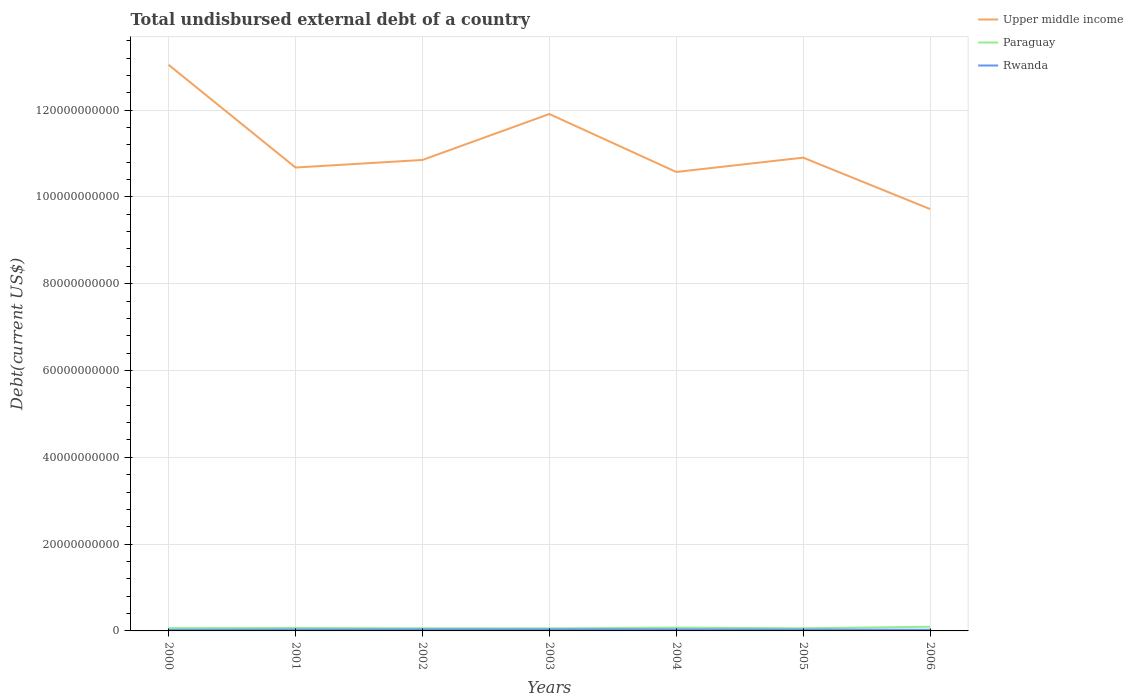Does the line corresponding to Rwanda intersect with the line corresponding to Upper middle income?
Offer a terse response. No. Is the number of lines equal to the number of legend labels?
Keep it short and to the point. Yes. Across all years, what is the maximum total undisbursed external debt in Upper middle income?
Provide a short and direct response. 9.72e+1. In which year was the total undisbursed external debt in Rwanda maximum?
Your answer should be very brief. 2000. What is the total total undisbursed external debt in Paraguay in the graph?
Offer a terse response. 4.14e+07. What is the difference between the highest and the second highest total undisbursed external debt in Upper middle income?
Offer a very short reply. 3.32e+1. Is the total undisbursed external debt in Paraguay strictly greater than the total undisbursed external debt in Rwanda over the years?
Offer a terse response. No. Are the values on the major ticks of Y-axis written in scientific E-notation?
Make the answer very short. No. Does the graph contain any zero values?
Provide a succinct answer. No. Where does the legend appear in the graph?
Make the answer very short. Top right. How many legend labels are there?
Ensure brevity in your answer.  3. How are the legend labels stacked?
Your answer should be compact. Vertical. What is the title of the graph?
Keep it short and to the point. Total undisbursed external debt of a country. Does "Lower middle income" appear as one of the legend labels in the graph?
Offer a very short reply. No. What is the label or title of the X-axis?
Offer a very short reply. Years. What is the label or title of the Y-axis?
Your answer should be compact. Debt(current US$). What is the Debt(current US$) in Upper middle income in 2000?
Your answer should be very brief. 1.30e+11. What is the Debt(current US$) of Paraguay in 2000?
Ensure brevity in your answer.  6.44e+08. What is the Debt(current US$) of Rwanda in 2000?
Provide a short and direct response. 2.42e+08. What is the Debt(current US$) of Upper middle income in 2001?
Offer a terse response. 1.07e+11. What is the Debt(current US$) in Paraguay in 2001?
Make the answer very short. 6.70e+08. What is the Debt(current US$) of Rwanda in 2001?
Your answer should be compact. 3.17e+08. What is the Debt(current US$) in Upper middle income in 2002?
Your answer should be compact. 1.09e+11. What is the Debt(current US$) of Paraguay in 2002?
Your answer should be compact. 6.13e+08. What is the Debt(current US$) in Rwanda in 2002?
Keep it short and to the point. 3.53e+08. What is the Debt(current US$) of Upper middle income in 2003?
Offer a terse response. 1.19e+11. What is the Debt(current US$) of Paraguay in 2003?
Make the answer very short. 5.88e+08. What is the Debt(current US$) in Rwanda in 2003?
Your answer should be compact. 3.61e+08. What is the Debt(current US$) of Upper middle income in 2004?
Keep it short and to the point. 1.06e+11. What is the Debt(current US$) in Paraguay in 2004?
Your answer should be compact. 7.51e+08. What is the Debt(current US$) in Rwanda in 2004?
Ensure brevity in your answer.  3.57e+08. What is the Debt(current US$) in Upper middle income in 2005?
Ensure brevity in your answer.  1.09e+11. What is the Debt(current US$) in Paraguay in 2005?
Give a very brief answer. 6.03e+08. What is the Debt(current US$) in Rwanda in 2005?
Provide a succinct answer. 3.08e+08. What is the Debt(current US$) of Upper middle income in 2006?
Give a very brief answer. 9.72e+1. What is the Debt(current US$) in Paraguay in 2006?
Provide a succinct answer. 9.66e+08. What is the Debt(current US$) in Rwanda in 2006?
Your response must be concise. 2.74e+08. Across all years, what is the maximum Debt(current US$) in Upper middle income?
Ensure brevity in your answer.  1.30e+11. Across all years, what is the maximum Debt(current US$) of Paraguay?
Make the answer very short. 9.66e+08. Across all years, what is the maximum Debt(current US$) in Rwanda?
Provide a short and direct response. 3.61e+08. Across all years, what is the minimum Debt(current US$) in Upper middle income?
Offer a very short reply. 9.72e+1. Across all years, what is the minimum Debt(current US$) in Paraguay?
Make the answer very short. 5.88e+08. Across all years, what is the minimum Debt(current US$) in Rwanda?
Ensure brevity in your answer.  2.42e+08. What is the total Debt(current US$) of Upper middle income in the graph?
Make the answer very short. 7.77e+11. What is the total Debt(current US$) in Paraguay in the graph?
Your response must be concise. 4.84e+09. What is the total Debt(current US$) of Rwanda in the graph?
Your response must be concise. 2.21e+09. What is the difference between the Debt(current US$) in Upper middle income in 2000 and that in 2001?
Keep it short and to the point. 2.37e+1. What is the difference between the Debt(current US$) of Paraguay in 2000 and that in 2001?
Your answer should be very brief. -2.57e+07. What is the difference between the Debt(current US$) in Rwanda in 2000 and that in 2001?
Your answer should be very brief. -7.55e+07. What is the difference between the Debt(current US$) of Upper middle income in 2000 and that in 2002?
Make the answer very short. 2.19e+1. What is the difference between the Debt(current US$) of Paraguay in 2000 and that in 2002?
Keep it short and to the point. 3.11e+07. What is the difference between the Debt(current US$) of Rwanda in 2000 and that in 2002?
Ensure brevity in your answer.  -1.12e+08. What is the difference between the Debt(current US$) of Upper middle income in 2000 and that in 2003?
Keep it short and to the point. 1.13e+1. What is the difference between the Debt(current US$) of Paraguay in 2000 and that in 2003?
Provide a short and direct response. 5.69e+07. What is the difference between the Debt(current US$) of Rwanda in 2000 and that in 2003?
Provide a succinct answer. -1.20e+08. What is the difference between the Debt(current US$) of Upper middle income in 2000 and that in 2004?
Make the answer very short. 2.47e+1. What is the difference between the Debt(current US$) of Paraguay in 2000 and that in 2004?
Provide a short and direct response. -1.06e+08. What is the difference between the Debt(current US$) of Rwanda in 2000 and that in 2004?
Provide a short and direct response. -1.16e+08. What is the difference between the Debt(current US$) in Upper middle income in 2000 and that in 2005?
Provide a succinct answer. 2.14e+1. What is the difference between the Debt(current US$) of Paraguay in 2000 and that in 2005?
Keep it short and to the point. 4.14e+07. What is the difference between the Debt(current US$) in Rwanda in 2000 and that in 2005?
Offer a very short reply. -6.67e+07. What is the difference between the Debt(current US$) in Upper middle income in 2000 and that in 2006?
Provide a short and direct response. 3.32e+1. What is the difference between the Debt(current US$) in Paraguay in 2000 and that in 2006?
Provide a short and direct response. -3.22e+08. What is the difference between the Debt(current US$) of Rwanda in 2000 and that in 2006?
Provide a short and direct response. -3.26e+07. What is the difference between the Debt(current US$) in Upper middle income in 2001 and that in 2002?
Your answer should be very brief. -1.75e+09. What is the difference between the Debt(current US$) in Paraguay in 2001 and that in 2002?
Keep it short and to the point. 5.68e+07. What is the difference between the Debt(current US$) of Rwanda in 2001 and that in 2002?
Provide a short and direct response. -3.62e+07. What is the difference between the Debt(current US$) of Upper middle income in 2001 and that in 2003?
Your response must be concise. -1.23e+1. What is the difference between the Debt(current US$) in Paraguay in 2001 and that in 2003?
Your response must be concise. 8.26e+07. What is the difference between the Debt(current US$) in Rwanda in 2001 and that in 2003?
Provide a short and direct response. -4.42e+07. What is the difference between the Debt(current US$) in Upper middle income in 2001 and that in 2004?
Provide a succinct answer. 1.02e+09. What is the difference between the Debt(current US$) in Paraguay in 2001 and that in 2004?
Your response must be concise. -8.05e+07. What is the difference between the Debt(current US$) in Rwanda in 2001 and that in 2004?
Offer a terse response. -4.03e+07. What is the difference between the Debt(current US$) in Upper middle income in 2001 and that in 2005?
Keep it short and to the point. -2.28e+09. What is the difference between the Debt(current US$) of Paraguay in 2001 and that in 2005?
Give a very brief answer. 6.71e+07. What is the difference between the Debt(current US$) in Rwanda in 2001 and that in 2005?
Offer a very short reply. 8.79e+06. What is the difference between the Debt(current US$) in Upper middle income in 2001 and that in 2006?
Your answer should be very brief. 9.57e+09. What is the difference between the Debt(current US$) in Paraguay in 2001 and that in 2006?
Make the answer very short. -2.96e+08. What is the difference between the Debt(current US$) of Rwanda in 2001 and that in 2006?
Your answer should be very brief. 4.29e+07. What is the difference between the Debt(current US$) of Upper middle income in 2002 and that in 2003?
Give a very brief answer. -1.06e+1. What is the difference between the Debt(current US$) of Paraguay in 2002 and that in 2003?
Your response must be concise. 2.58e+07. What is the difference between the Debt(current US$) in Rwanda in 2002 and that in 2003?
Your response must be concise. -8.06e+06. What is the difference between the Debt(current US$) in Upper middle income in 2002 and that in 2004?
Keep it short and to the point. 2.77e+09. What is the difference between the Debt(current US$) of Paraguay in 2002 and that in 2004?
Keep it short and to the point. -1.37e+08. What is the difference between the Debt(current US$) of Rwanda in 2002 and that in 2004?
Ensure brevity in your answer.  -4.13e+06. What is the difference between the Debt(current US$) in Upper middle income in 2002 and that in 2005?
Your response must be concise. -5.31e+08. What is the difference between the Debt(current US$) in Paraguay in 2002 and that in 2005?
Give a very brief answer. 1.03e+07. What is the difference between the Debt(current US$) in Rwanda in 2002 and that in 2005?
Make the answer very short. 4.50e+07. What is the difference between the Debt(current US$) of Upper middle income in 2002 and that in 2006?
Your response must be concise. 1.13e+1. What is the difference between the Debt(current US$) in Paraguay in 2002 and that in 2006?
Provide a succinct answer. -3.53e+08. What is the difference between the Debt(current US$) in Rwanda in 2002 and that in 2006?
Offer a very short reply. 7.90e+07. What is the difference between the Debt(current US$) of Upper middle income in 2003 and that in 2004?
Provide a short and direct response. 1.33e+1. What is the difference between the Debt(current US$) of Paraguay in 2003 and that in 2004?
Offer a very short reply. -1.63e+08. What is the difference between the Debt(current US$) in Rwanda in 2003 and that in 2004?
Your answer should be very brief. 3.93e+06. What is the difference between the Debt(current US$) in Upper middle income in 2003 and that in 2005?
Keep it short and to the point. 1.01e+1. What is the difference between the Debt(current US$) of Paraguay in 2003 and that in 2005?
Ensure brevity in your answer.  -1.55e+07. What is the difference between the Debt(current US$) of Rwanda in 2003 and that in 2005?
Your answer should be compact. 5.30e+07. What is the difference between the Debt(current US$) in Upper middle income in 2003 and that in 2006?
Make the answer very short. 2.19e+1. What is the difference between the Debt(current US$) of Paraguay in 2003 and that in 2006?
Your response must be concise. -3.79e+08. What is the difference between the Debt(current US$) of Rwanda in 2003 and that in 2006?
Your answer should be very brief. 8.71e+07. What is the difference between the Debt(current US$) in Upper middle income in 2004 and that in 2005?
Your answer should be very brief. -3.30e+09. What is the difference between the Debt(current US$) of Paraguay in 2004 and that in 2005?
Your response must be concise. 1.48e+08. What is the difference between the Debt(current US$) in Rwanda in 2004 and that in 2005?
Make the answer very short. 4.91e+07. What is the difference between the Debt(current US$) in Upper middle income in 2004 and that in 2006?
Provide a short and direct response. 8.55e+09. What is the difference between the Debt(current US$) of Paraguay in 2004 and that in 2006?
Keep it short and to the point. -2.16e+08. What is the difference between the Debt(current US$) in Rwanda in 2004 and that in 2006?
Your response must be concise. 8.32e+07. What is the difference between the Debt(current US$) in Upper middle income in 2005 and that in 2006?
Your answer should be compact. 1.18e+1. What is the difference between the Debt(current US$) in Paraguay in 2005 and that in 2006?
Your answer should be compact. -3.63e+08. What is the difference between the Debt(current US$) in Rwanda in 2005 and that in 2006?
Your answer should be very brief. 3.41e+07. What is the difference between the Debt(current US$) of Upper middle income in 2000 and the Debt(current US$) of Paraguay in 2001?
Your answer should be very brief. 1.30e+11. What is the difference between the Debt(current US$) in Upper middle income in 2000 and the Debt(current US$) in Rwanda in 2001?
Offer a very short reply. 1.30e+11. What is the difference between the Debt(current US$) of Paraguay in 2000 and the Debt(current US$) of Rwanda in 2001?
Make the answer very short. 3.27e+08. What is the difference between the Debt(current US$) in Upper middle income in 2000 and the Debt(current US$) in Paraguay in 2002?
Your answer should be very brief. 1.30e+11. What is the difference between the Debt(current US$) in Upper middle income in 2000 and the Debt(current US$) in Rwanda in 2002?
Offer a very short reply. 1.30e+11. What is the difference between the Debt(current US$) in Paraguay in 2000 and the Debt(current US$) in Rwanda in 2002?
Provide a short and direct response. 2.91e+08. What is the difference between the Debt(current US$) of Upper middle income in 2000 and the Debt(current US$) of Paraguay in 2003?
Provide a short and direct response. 1.30e+11. What is the difference between the Debt(current US$) of Upper middle income in 2000 and the Debt(current US$) of Rwanda in 2003?
Offer a terse response. 1.30e+11. What is the difference between the Debt(current US$) of Paraguay in 2000 and the Debt(current US$) of Rwanda in 2003?
Provide a succinct answer. 2.83e+08. What is the difference between the Debt(current US$) of Upper middle income in 2000 and the Debt(current US$) of Paraguay in 2004?
Ensure brevity in your answer.  1.30e+11. What is the difference between the Debt(current US$) of Upper middle income in 2000 and the Debt(current US$) of Rwanda in 2004?
Your answer should be very brief. 1.30e+11. What is the difference between the Debt(current US$) in Paraguay in 2000 and the Debt(current US$) in Rwanda in 2004?
Give a very brief answer. 2.87e+08. What is the difference between the Debt(current US$) of Upper middle income in 2000 and the Debt(current US$) of Paraguay in 2005?
Your response must be concise. 1.30e+11. What is the difference between the Debt(current US$) of Upper middle income in 2000 and the Debt(current US$) of Rwanda in 2005?
Provide a short and direct response. 1.30e+11. What is the difference between the Debt(current US$) of Paraguay in 2000 and the Debt(current US$) of Rwanda in 2005?
Provide a short and direct response. 3.36e+08. What is the difference between the Debt(current US$) in Upper middle income in 2000 and the Debt(current US$) in Paraguay in 2006?
Give a very brief answer. 1.29e+11. What is the difference between the Debt(current US$) of Upper middle income in 2000 and the Debt(current US$) of Rwanda in 2006?
Give a very brief answer. 1.30e+11. What is the difference between the Debt(current US$) in Paraguay in 2000 and the Debt(current US$) in Rwanda in 2006?
Ensure brevity in your answer.  3.70e+08. What is the difference between the Debt(current US$) in Upper middle income in 2001 and the Debt(current US$) in Paraguay in 2002?
Give a very brief answer. 1.06e+11. What is the difference between the Debt(current US$) in Upper middle income in 2001 and the Debt(current US$) in Rwanda in 2002?
Your answer should be compact. 1.06e+11. What is the difference between the Debt(current US$) in Paraguay in 2001 and the Debt(current US$) in Rwanda in 2002?
Provide a succinct answer. 3.17e+08. What is the difference between the Debt(current US$) in Upper middle income in 2001 and the Debt(current US$) in Paraguay in 2003?
Your response must be concise. 1.06e+11. What is the difference between the Debt(current US$) in Upper middle income in 2001 and the Debt(current US$) in Rwanda in 2003?
Offer a very short reply. 1.06e+11. What is the difference between the Debt(current US$) in Paraguay in 2001 and the Debt(current US$) in Rwanda in 2003?
Make the answer very short. 3.09e+08. What is the difference between the Debt(current US$) in Upper middle income in 2001 and the Debt(current US$) in Paraguay in 2004?
Ensure brevity in your answer.  1.06e+11. What is the difference between the Debt(current US$) of Upper middle income in 2001 and the Debt(current US$) of Rwanda in 2004?
Keep it short and to the point. 1.06e+11. What is the difference between the Debt(current US$) in Paraguay in 2001 and the Debt(current US$) in Rwanda in 2004?
Keep it short and to the point. 3.13e+08. What is the difference between the Debt(current US$) in Upper middle income in 2001 and the Debt(current US$) in Paraguay in 2005?
Offer a terse response. 1.06e+11. What is the difference between the Debt(current US$) in Upper middle income in 2001 and the Debt(current US$) in Rwanda in 2005?
Your answer should be very brief. 1.06e+11. What is the difference between the Debt(current US$) of Paraguay in 2001 and the Debt(current US$) of Rwanda in 2005?
Offer a very short reply. 3.62e+08. What is the difference between the Debt(current US$) in Upper middle income in 2001 and the Debt(current US$) in Paraguay in 2006?
Provide a succinct answer. 1.06e+11. What is the difference between the Debt(current US$) of Upper middle income in 2001 and the Debt(current US$) of Rwanda in 2006?
Your answer should be very brief. 1.06e+11. What is the difference between the Debt(current US$) in Paraguay in 2001 and the Debt(current US$) in Rwanda in 2006?
Your answer should be compact. 3.96e+08. What is the difference between the Debt(current US$) of Upper middle income in 2002 and the Debt(current US$) of Paraguay in 2003?
Provide a short and direct response. 1.08e+11. What is the difference between the Debt(current US$) in Upper middle income in 2002 and the Debt(current US$) in Rwanda in 2003?
Your response must be concise. 1.08e+11. What is the difference between the Debt(current US$) of Paraguay in 2002 and the Debt(current US$) of Rwanda in 2003?
Your answer should be very brief. 2.52e+08. What is the difference between the Debt(current US$) in Upper middle income in 2002 and the Debt(current US$) in Paraguay in 2004?
Offer a terse response. 1.08e+11. What is the difference between the Debt(current US$) in Upper middle income in 2002 and the Debt(current US$) in Rwanda in 2004?
Give a very brief answer. 1.08e+11. What is the difference between the Debt(current US$) of Paraguay in 2002 and the Debt(current US$) of Rwanda in 2004?
Offer a very short reply. 2.56e+08. What is the difference between the Debt(current US$) in Upper middle income in 2002 and the Debt(current US$) in Paraguay in 2005?
Offer a terse response. 1.08e+11. What is the difference between the Debt(current US$) of Upper middle income in 2002 and the Debt(current US$) of Rwanda in 2005?
Make the answer very short. 1.08e+11. What is the difference between the Debt(current US$) in Paraguay in 2002 and the Debt(current US$) in Rwanda in 2005?
Offer a terse response. 3.05e+08. What is the difference between the Debt(current US$) in Upper middle income in 2002 and the Debt(current US$) in Paraguay in 2006?
Offer a very short reply. 1.08e+11. What is the difference between the Debt(current US$) of Upper middle income in 2002 and the Debt(current US$) of Rwanda in 2006?
Offer a very short reply. 1.08e+11. What is the difference between the Debt(current US$) of Paraguay in 2002 and the Debt(current US$) of Rwanda in 2006?
Provide a short and direct response. 3.39e+08. What is the difference between the Debt(current US$) in Upper middle income in 2003 and the Debt(current US$) in Paraguay in 2004?
Keep it short and to the point. 1.18e+11. What is the difference between the Debt(current US$) in Upper middle income in 2003 and the Debt(current US$) in Rwanda in 2004?
Your response must be concise. 1.19e+11. What is the difference between the Debt(current US$) in Paraguay in 2003 and the Debt(current US$) in Rwanda in 2004?
Give a very brief answer. 2.30e+08. What is the difference between the Debt(current US$) of Upper middle income in 2003 and the Debt(current US$) of Paraguay in 2005?
Provide a succinct answer. 1.18e+11. What is the difference between the Debt(current US$) in Upper middle income in 2003 and the Debt(current US$) in Rwanda in 2005?
Your answer should be compact. 1.19e+11. What is the difference between the Debt(current US$) in Paraguay in 2003 and the Debt(current US$) in Rwanda in 2005?
Offer a very short reply. 2.79e+08. What is the difference between the Debt(current US$) in Upper middle income in 2003 and the Debt(current US$) in Paraguay in 2006?
Provide a succinct answer. 1.18e+11. What is the difference between the Debt(current US$) in Upper middle income in 2003 and the Debt(current US$) in Rwanda in 2006?
Provide a short and direct response. 1.19e+11. What is the difference between the Debt(current US$) in Paraguay in 2003 and the Debt(current US$) in Rwanda in 2006?
Offer a very short reply. 3.13e+08. What is the difference between the Debt(current US$) in Upper middle income in 2004 and the Debt(current US$) in Paraguay in 2005?
Your answer should be compact. 1.05e+11. What is the difference between the Debt(current US$) in Upper middle income in 2004 and the Debt(current US$) in Rwanda in 2005?
Ensure brevity in your answer.  1.05e+11. What is the difference between the Debt(current US$) of Paraguay in 2004 and the Debt(current US$) of Rwanda in 2005?
Offer a terse response. 4.42e+08. What is the difference between the Debt(current US$) in Upper middle income in 2004 and the Debt(current US$) in Paraguay in 2006?
Your response must be concise. 1.05e+11. What is the difference between the Debt(current US$) in Upper middle income in 2004 and the Debt(current US$) in Rwanda in 2006?
Provide a succinct answer. 1.05e+11. What is the difference between the Debt(current US$) of Paraguay in 2004 and the Debt(current US$) of Rwanda in 2006?
Your answer should be very brief. 4.76e+08. What is the difference between the Debt(current US$) in Upper middle income in 2005 and the Debt(current US$) in Paraguay in 2006?
Make the answer very short. 1.08e+11. What is the difference between the Debt(current US$) of Upper middle income in 2005 and the Debt(current US$) of Rwanda in 2006?
Your response must be concise. 1.09e+11. What is the difference between the Debt(current US$) in Paraguay in 2005 and the Debt(current US$) in Rwanda in 2006?
Your answer should be very brief. 3.29e+08. What is the average Debt(current US$) in Upper middle income per year?
Provide a short and direct response. 1.11e+11. What is the average Debt(current US$) of Paraguay per year?
Make the answer very short. 6.91e+08. What is the average Debt(current US$) in Rwanda per year?
Provide a succinct answer. 3.16e+08. In the year 2000, what is the difference between the Debt(current US$) of Upper middle income and Debt(current US$) of Paraguay?
Your answer should be very brief. 1.30e+11. In the year 2000, what is the difference between the Debt(current US$) of Upper middle income and Debt(current US$) of Rwanda?
Offer a terse response. 1.30e+11. In the year 2000, what is the difference between the Debt(current US$) of Paraguay and Debt(current US$) of Rwanda?
Give a very brief answer. 4.03e+08. In the year 2001, what is the difference between the Debt(current US$) in Upper middle income and Debt(current US$) in Paraguay?
Give a very brief answer. 1.06e+11. In the year 2001, what is the difference between the Debt(current US$) in Upper middle income and Debt(current US$) in Rwanda?
Give a very brief answer. 1.06e+11. In the year 2001, what is the difference between the Debt(current US$) in Paraguay and Debt(current US$) in Rwanda?
Offer a terse response. 3.53e+08. In the year 2002, what is the difference between the Debt(current US$) in Upper middle income and Debt(current US$) in Paraguay?
Make the answer very short. 1.08e+11. In the year 2002, what is the difference between the Debt(current US$) of Upper middle income and Debt(current US$) of Rwanda?
Offer a terse response. 1.08e+11. In the year 2002, what is the difference between the Debt(current US$) in Paraguay and Debt(current US$) in Rwanda?
Your answer should be compact. 2.60e+08. In the year 2003, what is the difference between the Debt(current US$) of Upper middle income and Debt(current US$) of Paraguay?
Make the answer very short. 1.19e+11. In the year 2003, what is the difference between the Debt(current US$) in Upper middle income and Debt(current US$) in Rwanda?
Give a very brief answer. 1.19e+11. In the year 2003, what is the difference between the Debt(current US$) in Paraguay and Debt(current US$) in Rwanda?
Provide a succinct answer. 2.26e+08. In the year 2004, what is the difference between the Debt(current US$) in Upper middle income and Debt(current US$) in Paraguay?
Offer a terse response. 1.05e+11. In the year 2004, what is the difference between the Debt(current US$) in Upper middle income and Debt(current US$) in Rwanda?
Ensure brevity in your answer.  1.05e+11. In the year 2004, what is the difference between the Debt(current US$) in Paraguay and Debt(current US$) in Rwanda?
Ensure brevity in your answer.  3.93e+08. In the year 2005, what is the difference between the Debt(current US$) of Upper middle income and Debt(current US$) of Paraguay?
Provide a short and direct response. 1.08e+11. In the year 2005, what is the difference between the Debt(current US$) in Upper middle income and Debt(current US$) in Rwanda?
Ensure brevity in your answer.  1.09e+11. In the year 2005, what is the difference between the Debt(current US$) in Paraguay and Debt(current US$) in Rwanda?
Your response must be concise. 2.95e+08. In the year 2006, what is the difference between the Debt(current US$) of Upper middle income and Debt(current US$) of Paraguay?
Keep it short and to the point. 9.62e+1. In the year 2006, what is the difference between the Debt(current US$) of Upper middle income and Debt(current US$) of Rwanda?
Keep it short and to the point. 9.69e+1. In the year 2006, what is the difference between the Debt(current US$) in Paraguay and Debt(current US$) in Rwanda?
Ensure brevity in your answer.  6.92e+08. What is the ratio of the Debt(current US$) of Upper middle income in 2000 to that in 2001?
Make the answer very short. 1.22. What is the ratio of the Debt(current US$) in Paraguay in 2000 to that in 2001?
Keep it short and to the point. 0.96. What is the ratio of the Debt(current US$) in Rwanda in 2000 to that in 2001?
Give a very brief answer. 0.76. What is the ratio of the Debt(current US$) in Upper middle income in 2000 to that in 2002?
Offer a very short reply. 1.2. What is the ratio of the Debt(current US$) in Paraguay in 2000 to that in 2002?
Offer a very short reply. 1.05. What is the ratio of the Debt(current US$) in Rwanda in 2000 to that in 2002?
Your answer should be compact. 0.68. What is the ratio of the Debt(current US$) of Upper middle income in 2000 to that in 2003?
Give a very brief answer. 1.1. What is the ratio of the Debt(current US$) in Paraguay in 2000 to that in 2003?
Make the answer very short. 1.1. What is the ratio of the Debt(current US$) of Rwanda in 2000 to that in 2003?
Your answer should be very brief. 0.67. What is the ratio of the Debt(current US$) of Upper middle income in 2000 to that in 2004?
Your response must be concise. 1.23. What is the ratio of the Debt(current US$) of Paraguay in 2000 to that in 2004?
Offer a very short reply. 0.86. What is the ratio of the Debt(current US$) in Rwanda in 2000 to that in 2004?
Give a very brief answer. 0.68. What is the ratio of the Debt(current US$) in Upper middle income in 2000 to that in 2005?
Your response must be concise. 1.2. What is the ratio of the Debt(current US$) of Paraguay in 2000 to that in 2005?
Provide a succinct answer. 1.07. What is the ratio of the Debt(current US$) in Rwanda in 2000 to that in 2005?
Offer a terse response. 0.78. What is the ratio of the Debt(current US$) of Upper middle income in 2000 to that in 2006?
Your response must be concise. 1.34. What is the ratio of the Debt(current US$) in Paraguay in 2000 to that in 2006?
Offer a very short reply. 0.67. What is the ratio of the Debt(current US$) of Rwanda in 2000 to that in 2006?
Give a very brief answer. 0.88. What is the ratio of the Debt(current US$) of Upper middle income in 2001 to that in 2002?
Provide a succinct answer. 0.98. What is the ratio of the Debt(current US$) in Paraguay in 2001 to that in 2002?
Your answer should be very brief. 1.09. What is the ratio of the Debt(current US$) in Rwanda in 2001 to that in 2002?
Keep it short and to the point. 0.9. What is the ratio of the Debt(current US$) in Upper middle income in 2001 to that in 2003?
Your answer should be very brief. 0.9. What is the ratio of the Debt(current US$) in Paraguay in 2001 to that in 2003?
Ensure brevity in your answer.  1.14. What is the ratio of the Debt(current US$) in Rwanda in 2001 to that in 2003?
Your answer should be compact. 0.88. What is the ratio of the Debt(current US$) in Upper middle income in 2001 to that in 2004?
Provide a succinct answer. 1.01. What is the ratio of the Debt(current US$) of Paraguay in 2001 to that in 2004?
Ensure brevity in your answer.  0.89. What is the ratio of the Debt(current US$) of Rwanda in 2001 to that in 2004?
Your answer should be very brief. 0.89. What is the ratio of the Debt(current US$) in Upper middle income in 2001 to that in 2005?
Keep it short and to the point. 0.98. What is the ratio of the Debt(current US$) in Paraguay in 2001 to that in 2005?
Provide a succinct answer. 1.11. What is the ratio of the Debt(current US$) of Rwanda in 2001 to that in 2005?
Offer a very short reply. 1.03. What is the ratio of the Debt(current US$) of Upper middle income in 2001 to that in 2006?
Your answer should be compact. 1.1. What is the ratio of the Debt(current US$) in Paraguay in 2001 to that in 2006?
Make the answer very short. 0.69. What is the ratio of the Debt(current US$) in Rwanda in 2001 to that in 2006?
Offer a very short reply. 1.16. What is the ratio of the Debt(current US$) in Upper middle income in 2002 to that in 2003?
Your answer should be compact. 0.91. What is the ratio of the Debt(current US$) in Paraguay in 2002 to that in 2003?
Provide a short and direct response. 1.04. What is the ratio of the Debt(current US$) in Rwanda in 2002 to that in 2003?
Ensure brevity in your answer.  0.98. What is the ratio of the Debt(current US$) in Upper middle income in 2002 to that in 2004?
Keep it short and to the point. 1.03. What is the ratio of the Debt(current US$) in Paraguay in 2002 to that in 2004?
Ensure brevity in your answer.  0.82. What is the ratio of the Debt(current US$) of Upper middle income in 2002 to that in 2005?
Your response must be concise. 1. What is the ratio of the Debt(current US$) of Paraguay in 2002 to that in 2005?
Make the answer very short. 1.02. What is the ratio of the Debt(current US$) in Rwanda in 2002 to that in 2005?
Your answer should be compact. 1.15. What is the ratio of the Debt(current US$) of Upper middle income in 2002 to that in 2006?
Provide a short and direct response. 1.12. What is the ratio of the Debt(current US$) of Paraguay in 2002 to that in 2006?
Provide a succinct answer. 0.63. What is the ratio of the Debt(current US$) of Rwanda in 2002 to that in 2006?
Give a very brief answer. 1.29. What is the ratio of the Debt(current US$) of Upper middle income in 2003 to that in 2004?
Keep it short and to the point. 1.13. What is the ratio of the Debt(current US$) in Paraguay in 2003 to that in 2004?
Keep it short and to the point. 0.78. What is the ratio of the Debt(current US$) in Upper middle income in 2003 to that in 2005?
Give a very brief answer. 1.09. What is the ratio of the Debt(current US$) of Paraguay in 2003 to that in 2005?
Keep it short and to the point. 0.97. What is the ratio of the Debt(current US$) of Rwanda in 2003 to that in 2005?
Offer a terse response. 1.17. What is the ratio of the Debt(current US$) in Upper middle income in 2003 to that in 2006?
Offer a terse response. 1.23. What is the ratio of the Debt(current US$) of Paraguay in 2003 to that in 2006?
Offer a very short reply. 0.61. What is the ratio of the Debt(current US$) in Rwanda in 2003 to that in 2006?
Provide a succinct answer. 1.32. What is the ratio of the Debt(current US$) of Upper middle income in 2004 to that in 2005?
Give a very brief answer. 0.97. What is the ratio of the Debt(current US$) in Paraguay in 2004 to that in 2005?
Provide a succinct answer. 1.24. What is the ratio of the Debt(current US$) of Rwanda in 2004 to that in 2005?
Make the answer very short. 1.16. What is the ratio of the Debt(current US$) of Upper middle income in 2004 to that in 2006?
Offer a very short reply. 1.09. What is the ratio of the Debt(current US$) in Paraguay in 2004 to that in 2006?
Provide a short and direct response. 0.78. What is the ratio of the Debt(current US$) in Rwanda in 2004 to that in 2006?
Offer a very short reply. 1.3. What is the ratio of the Debt(current US$) of Upper middle income in 2005 to that in 2006?
Your answer should be very brief. 1.12. What is the ratio of the Debt(current US$) in Paraguay in 2005 to that in 2006?
Give a very brief answer. 0.62. What is the ratio of the Debt(current US$) of Rwanda in 2005 to that in 2006?
Keep it short and to the point. 1.12. What is the difference between the highest and the second highest Debt(current US$) of Upper middle income?
Provide a short and direct response. 1.13e+1. What is the difference between the highest and the second highest Debt(current US$) in Paraguay?
Provide a succinct answer. 2.16e+08. What is the difference between the highest and the second highest Debt(current US$) in Rwanda?
Offer a very short reply. 3.93e+06. What is the difference between the highest and the lowest Debt(current US$) of Upper middle income?
Your answer should be compact. 3.32e+1. What is the difference between the highest and the lowest Debt(current US$) in Paraguay?
Your response must be concise. 3.79e+08. What is the difference between the highest and the lowest Debt(current US$) of Rwanda?
Provide a short and direct response. 1.20e+08. 